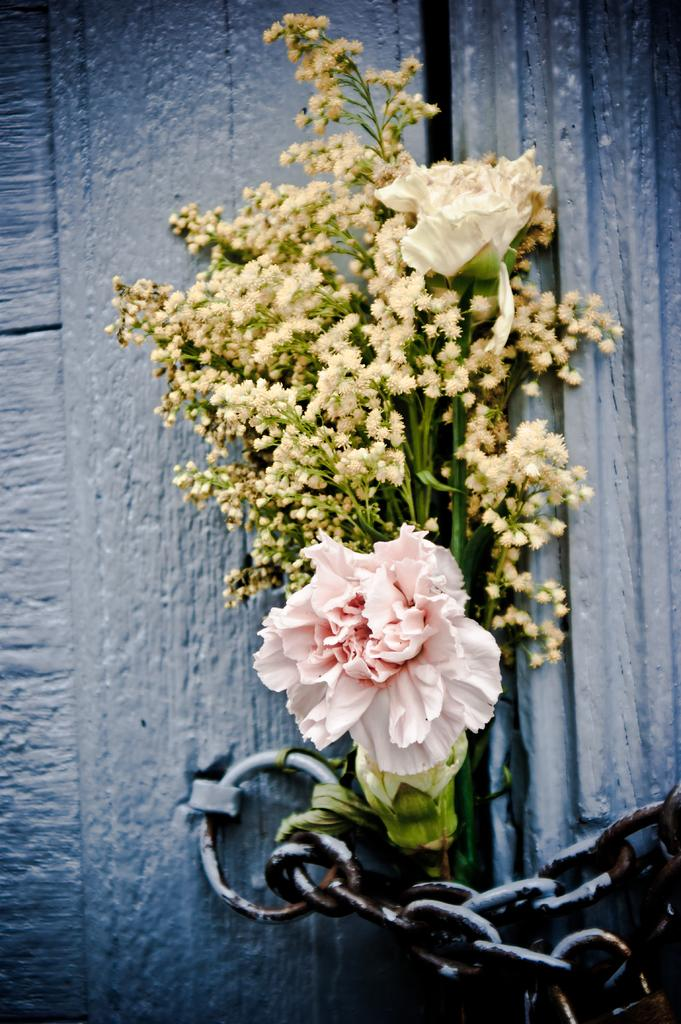What type of vegetation can be seen in the front of the image? There are flowers in the front of the image. What is located at the bottom of the image? There is a chain at the bottom of the image. What structure is visible in the background of the image? There is a door visible in the background of the image. What type of beef is being prepared in the image? There is no beef present in the image; it features flowers, a chain, and a door. What is the source of the shock in the image? There is no shock present in the image; it is a still image featuring flowers, a chain, and a door. 